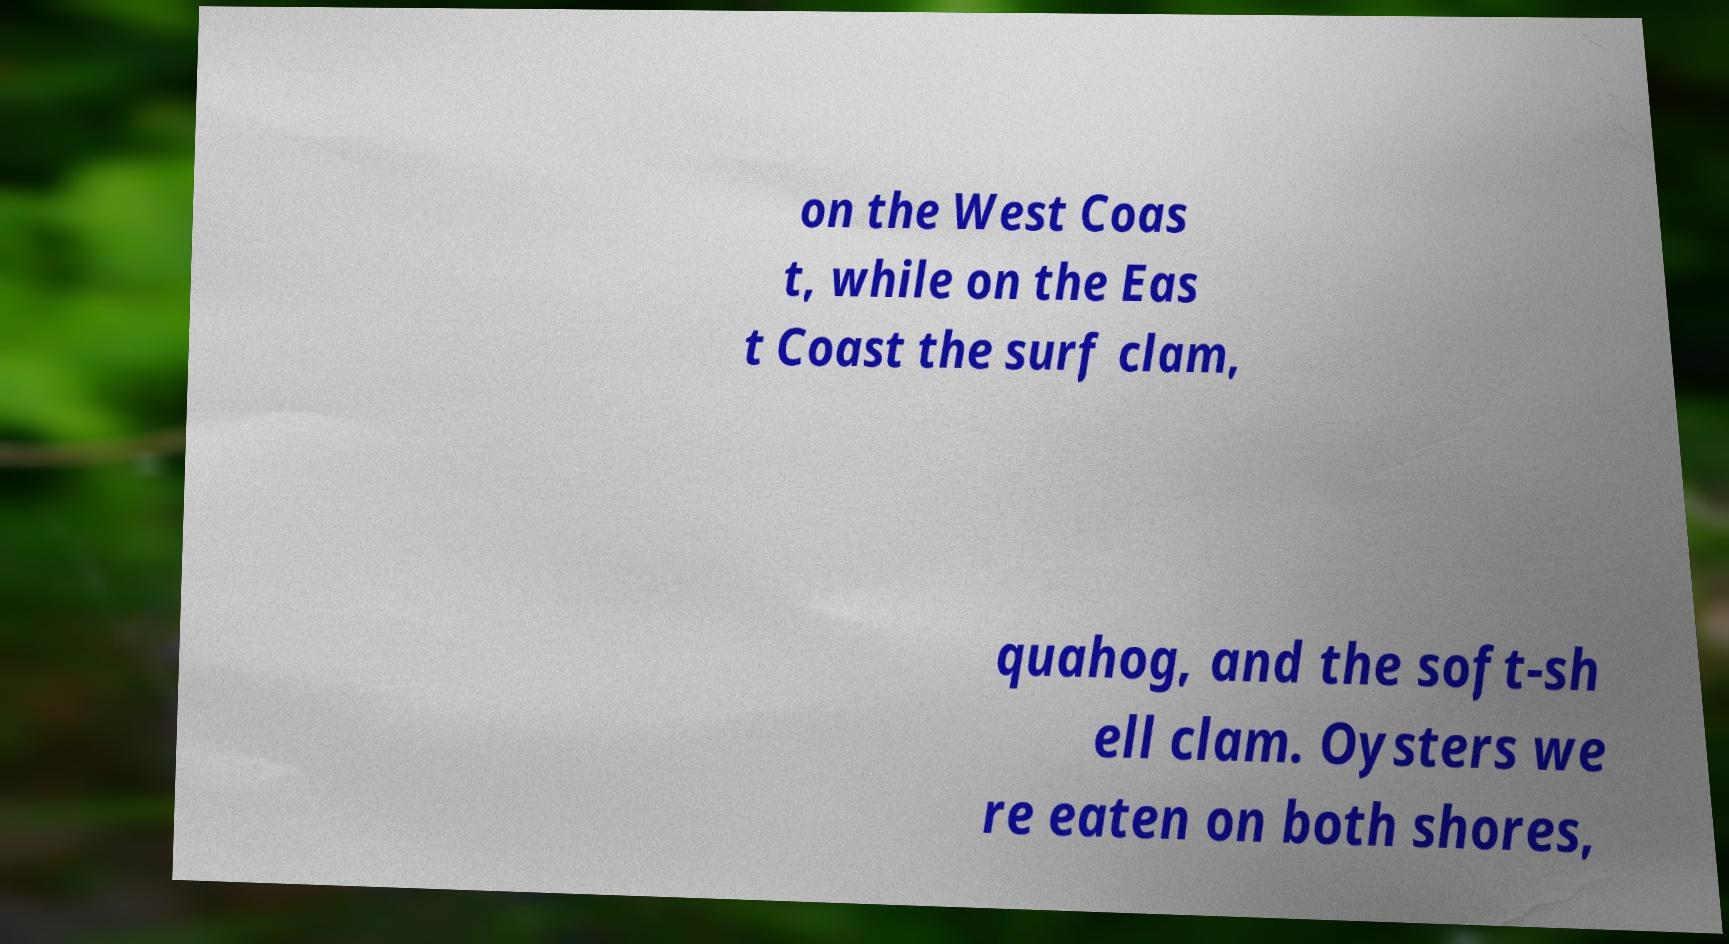What messages or text are displayed in this image? I need them in a readable, typed format. on the West Coas t, while on the Eas t Coast the surf clam, quahog, and the soft-sh ell clam. Oysters we re eaten on both shores, 